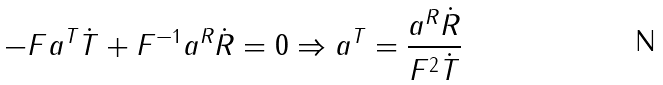Convert formula to latex. <formula><loc_0><loc_0><loc_500><loc_500>- F a ^ { T } \dot { T } + F ^ { - 1 } a ^ { R } \dot { R } = 0 \Rightarrow a ^ { T } = \frac { a ^ { R } \dot { R } } { F ^ { 2 } \dot { T } }</formula> 